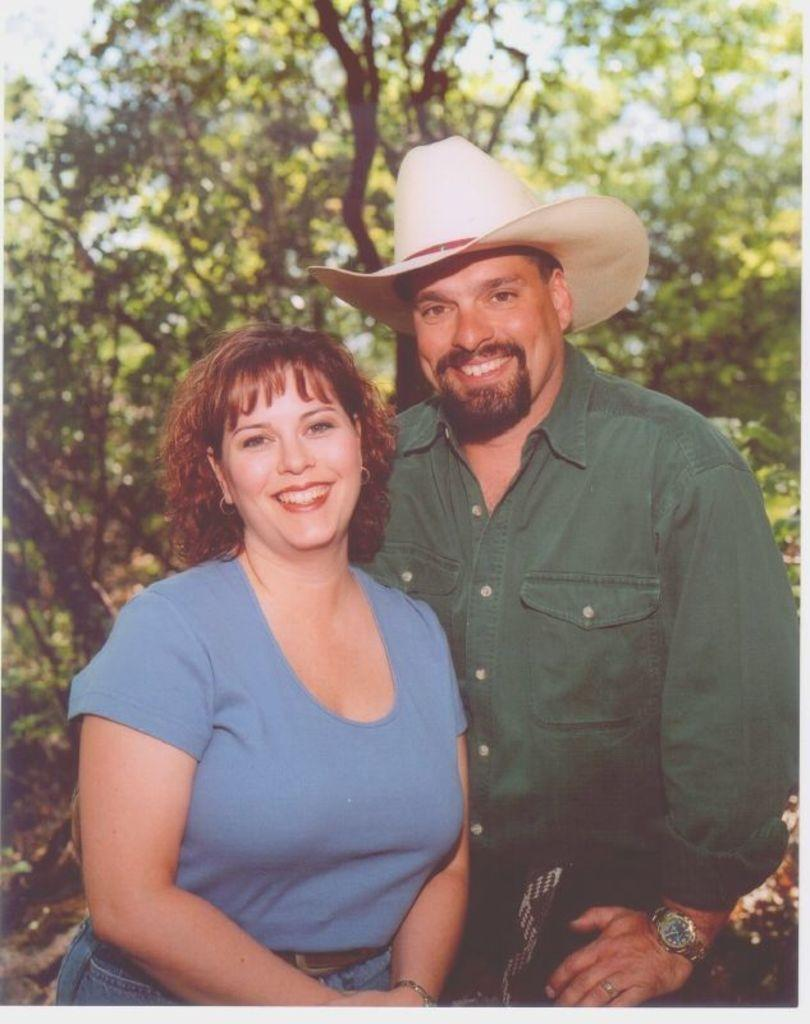How many people are in the image? There are persons in the image. What expression do the persons have? The persons are smiling. What can be seen in the background of the image? There are trees in the background of the image. What type of boundary can be seen in the image? There is no boundary present in the image. What color are the eyes of the persons in the image? The image does not show the persons' eyes, so we cannot determine their color. 